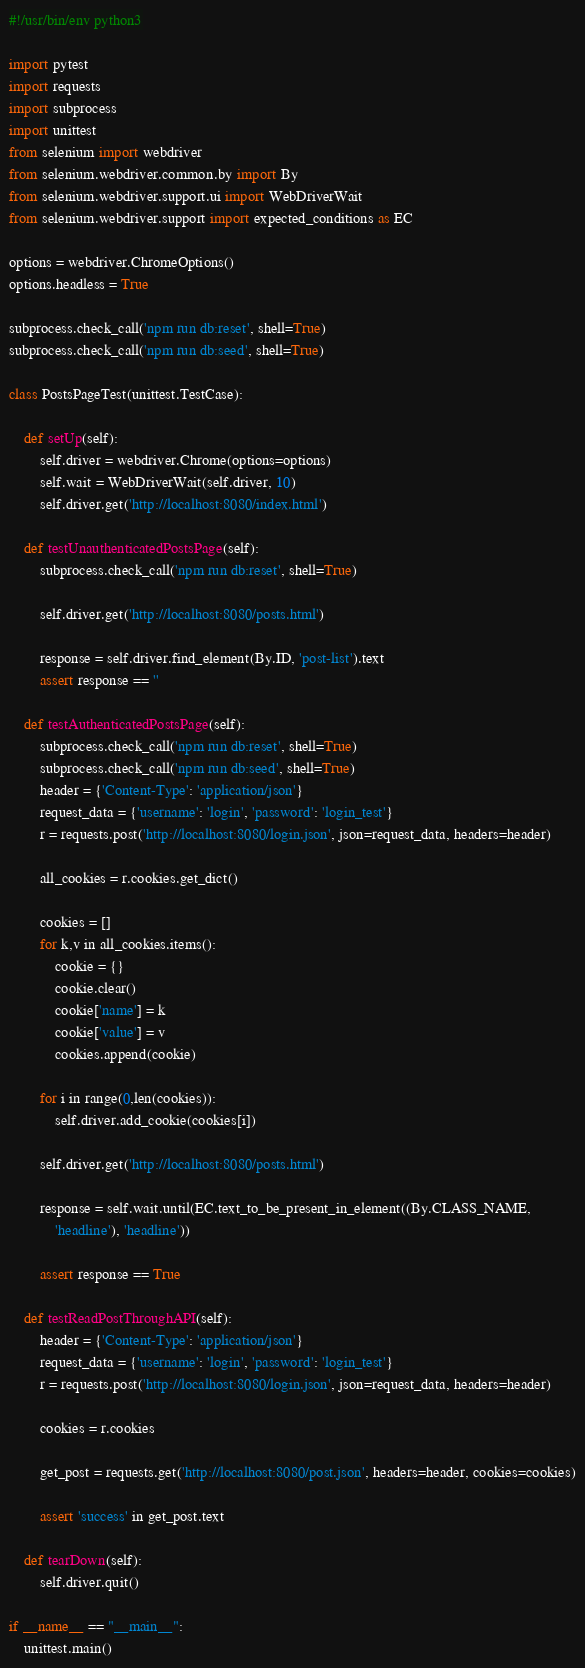<code> <loc_0><loc_0><loc_500><loc_500><_Python_>#!/usr/bin/env python3

import pytest
import requests
import subprocess
import unittest
from selenium import webdriver
from selenium.webdriver.common.by import By
from selenium.webdriver.support.ui import WebDriverWait
from selenium.webdriver.support import expected_conditions as EC

options = webdriver.ChromeOptions()
options.headless = True

subprocess.check_call('npm run db:reset', shell=True)
subprocess.check_call('npm run db:seed', shell=True)

class PostsPageTest(unittest.TestCase):

    def setUp(self):
        self.driver = webdriver.Chrome(options=options)
        self.wait = WebDriverWait(self.driver, 10)
        self.driver.get('http://localhost:8080/index.html')

    def testUnauthenticatedPostsPage(self):
        subprocess.check_call('npm run db:reset', shell=True)

        self.driver.get('http://localhost:8080/posts.html')

        response = self.driver.find_element(By.ID, 'post-list').text
        assert response == ''

    def testAuthenticatedPostsPage(self):
        subprocess.check_call('npm run db:reset', shell=True)
        subprocess.check_call('npm run db:seed', shell=True)
        header = {'Content-Type': 'application/json'}
        request_data = {'username': 'login', 'password': 'login_test'}
        r = requests.post('http://localhost:8080/login.json', json=request_data, headers=header)

        all_cookies = r.cookies.get_dict()

        cookies = []
        for k,v in all_cookies.items():
            cookie = {}
            cookie.clear()
            cookie['name'] = k
            cookie['value'] = v
            cookies.append(cookie)

        for i in range(0,len(cookies)):
            self.driver.add_cookie(cookies[i])

        self.driver.get('http://localhost:8080/posts.html')

        response = self.wait.until(EC.text_to_be_present_in_element((By.CLASS_NAME,
            'headline'), 'headline'))

        assert response == True
  
    def testReadPostThroughAPI(self):
        header = {'Content-Type': 'application/json'}
        request_data = {'username': 'login', 'password': 'login_test'}
        r = requests.post('http://localhost:8080/login.json', json=request_data, headers=header)
 
        cookies = r.cookies
 
        get_post = requests.get('http://localhost:8080/post.json', headers=header, cookies=cookies)
 
        assert 'success' in get_post.text 

    def tearDown(self):
        self.driver.quit()

if __name__ == "__main__":
    unittest.main()</code> 